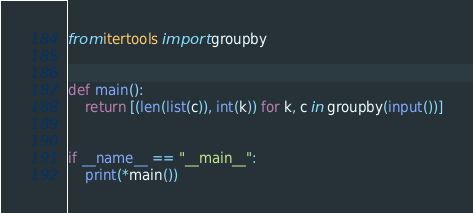<code> <loc_0><loc_0><loc_500><loc_500><_Python_>from itertools import groupby


def main():
    return [(len(list(c)), int(k)) for k, c in groupby(input())]


if __name__ == "__main__":
    print(*main())
</code> 